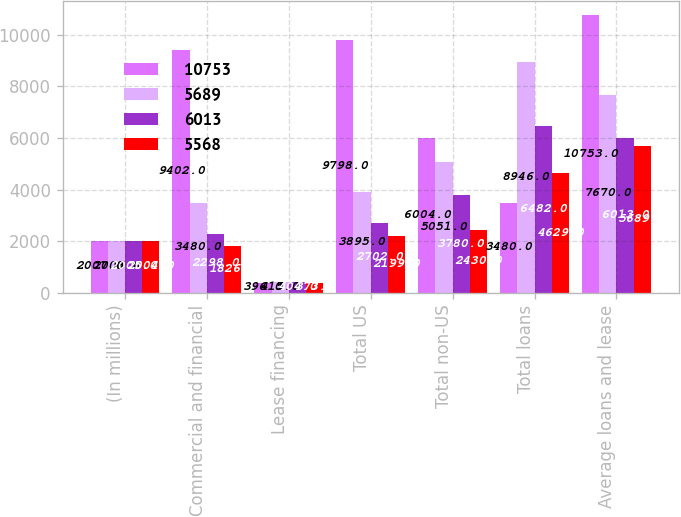<chart> <loc_0><loc_0><loc_500><loc_500><stacked_bar_chart><ecel><fcel>(In millions)<fcel>Commercial and financial<fcel>Lease financing<fcel>Total US<fcel>Total non-US<fcel>Total loans<fcel>Average loans and lease<nl><fcel>10753<fcel>2007<fcel>9402<fcel>396<fcel>9798<fcel>6004<fcel>3480<fcel>10753<nl><fcel>5689<fcel>2006<fcel>3480<fcel>415<fcel>3895<fcel>5051<fcel>8946<fcel>7670<nl><fcel>6013<fcel>2005<fcel>2298<fcel>404<fcel>2702<fcel>3780<fcel>6482<fcel>6013<nl><fcel>5568<fcel>2004<fcel>1826<fcel>373<fcel>2199<fcel>2430<fcel>4629<fcel>5689<nl></chart> 